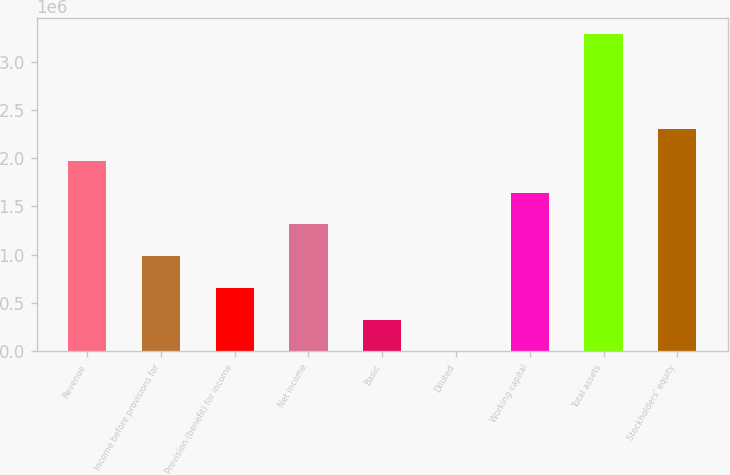Convert chart to OTSL. <chart><loc_0><loc_0><loc_500><loc_500><bar_chart><fcel>Revenue<fcel>Income before provisions for<fcel>Provision (benefit) for income<fcel>Net income<fcel>Basic<fcel>Diluted<fcel>Working capital<fcel>Total assets<fcel>Stockholders' equity<nl><fcel>1.97193e+06<fcel>985963<fcel>657309<fcel>1.31462e+06<fcel>328656<fcel>1.56<fcel>1.64327e+06<fcel>3.28654e+06<fcel>2.30058e+06<nl></chart> 